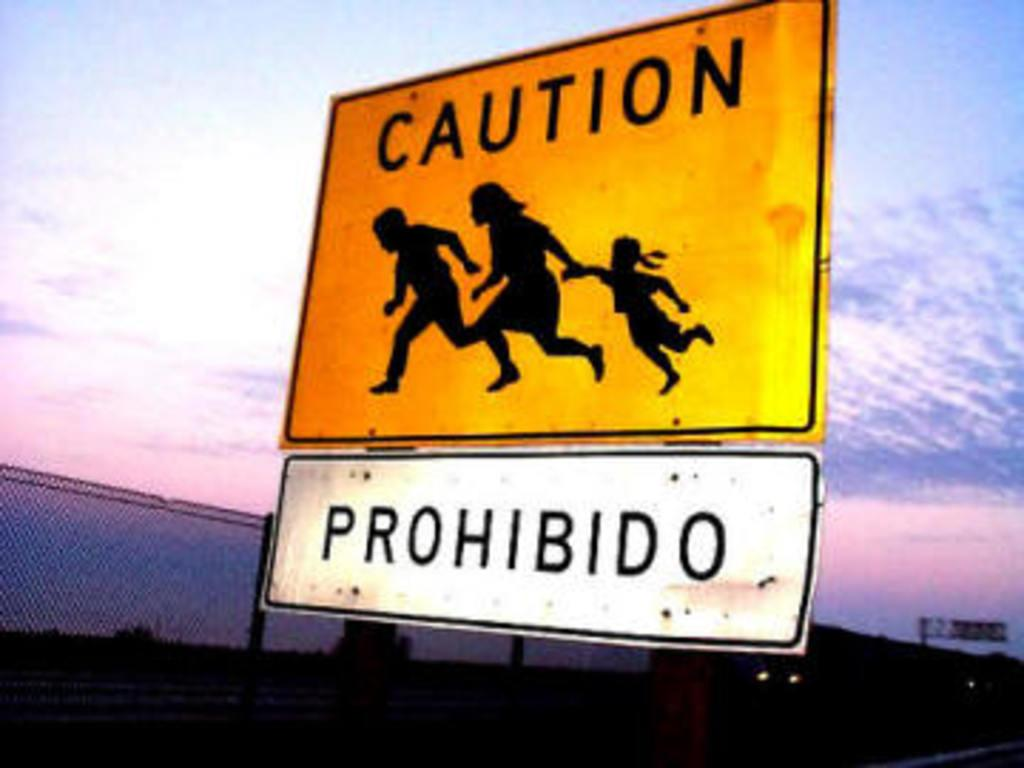<image>
Provide a brief description of the given image. An orange caution sign with the sunset in the background. 